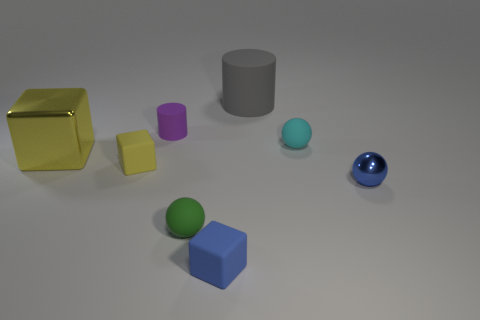Do the large object in front of the big gray matte thing and the sphere that is to the right of the cyan matte sphere have the same material?
Offer a very short reply. Yes. There is a big thing that is behind the small purple thing; what shape is it?
Keep it short and to the point. Cylinder. What size is the blue shiny thing that is the same shape as the green thing?
Give a very brief answer. Small. Do the large cylinder and the large cube have the same color?
Keep it short and to the point. No. Are there any other things that have the same shape as the big yellow object?
Give a very brief answer. Yes. There is a big shiny thing that is left of the green matte thing; is there a large yellow metal thing left of it?
Keep it short and to the point. No. There is another tiny thing that is the same shape as the tiny yellow thing; what color is it?
Your answer should be very brief. Blue. What number of rubber objects have the same color as the large metallic block?
Make the answer very short. 1. What is the color of the matte sphere that is in front of the tiny sphere to the right of the sphere that is behind the tiny yellow matte cube?
Ensure brevity in your answer.  Green. Is the purple cylinder made of the same material as the gray cylinder?
Offer a very short reply. Yes. 